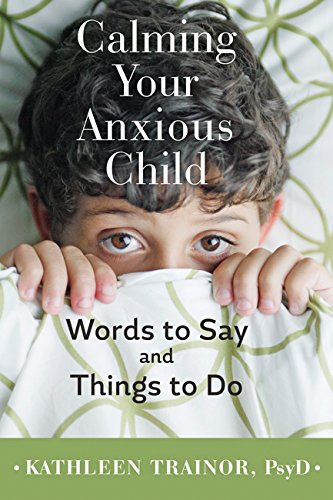What is the title of this book? The title of the book is 'Calming Your Anxious Child: Words to Say and Things to Do', a guide aimed at helping parents manage their child's anxiety. 